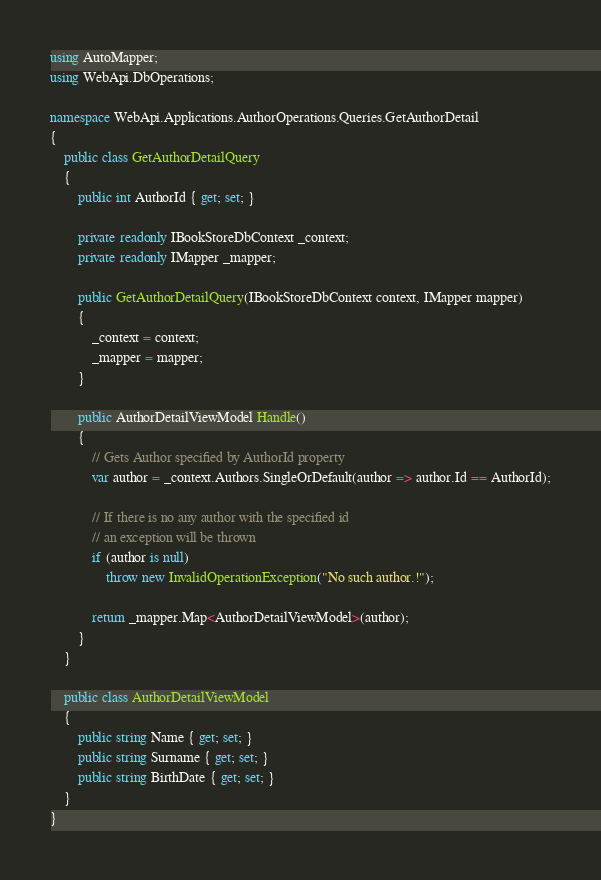<code> <loc_0><loc_0><loc_500><loc_500><_C#_>using AutoMapper;
using WebApi.DbOperations;

namespace WebApi.Applications.AuthorOperations.Queries.GetAuthorDetail
{
    public class GetAuthorDetailQuery
    {
        public int AuthorId { get; set; }

        private readonly IBookStoreDbContext _context;
        private readonly IMapper _mapper;

        public GetAuthorDetailQuery(IBookStoreDbContext context, IMapper mapper)
        {
            _context = context;
            _mapper = mapper;
        }

        public AuthorDetailViewModel Handle()
        {
            // Gets Author specified by AuthorId property
            var author = _context.Authors.SingleOrDefault(author => author.Id == AuthorId);

            // If there is no any author with the specified id 
            // an exception will be thrown
            if (author is null)
                throw new InvalidOperationException("No such author.!");

            return _mapper.Map<AuthorDetailViewModel>(author);
        }
    }

    public class AuthorDetailViewModel
    {
        public string Name { get; set; }
        public string Surname { get; set; }
        public string BirthDate { get; set; }
    }
}</code> 